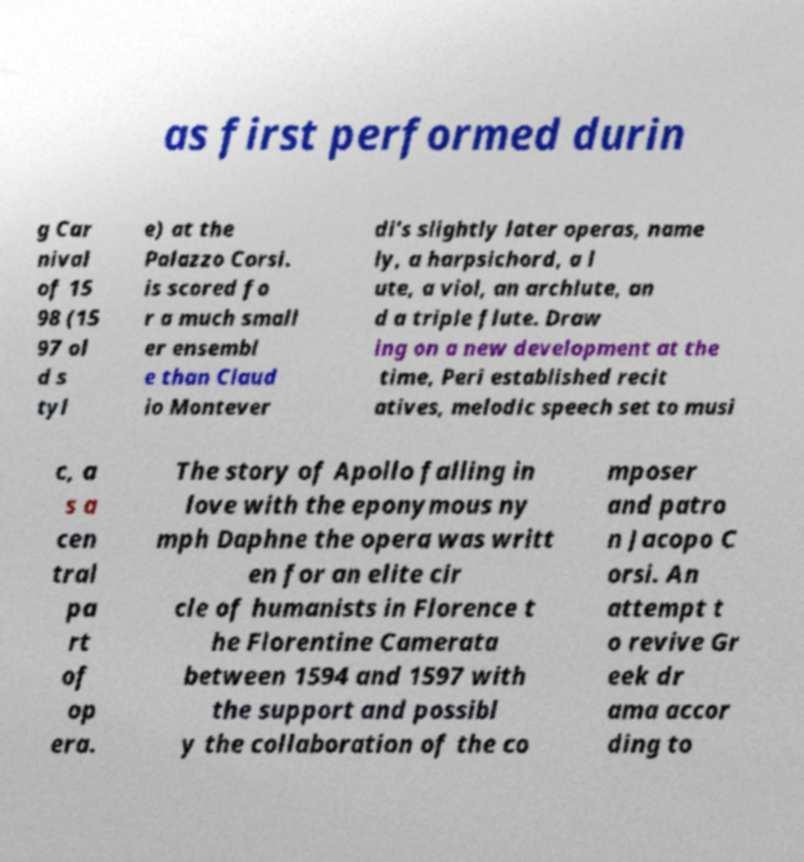Could you extract and type out the text from this image? as first performed durin g Car nival of 15 98 (15 97 ol d s tyl e) at the Palazzo Corsi. is scored fo r a much small er ensembl e than Claud io Montever di's slightly later operas, name ly, a harpsichord, a l ute, a viol, an archlute, an d a triple flute. Draw ing on a new development at the time, Peri established recit atives, melodic speech set to musi c, a s a cen tral pa rt of op era. The story of Apollo falling in love with the eponymous ny mph Daphne the opera was writt en for an elite cir cle of humanists in Florence t he Florentine Camerata between 1594 and 1597 with the support and possibl y the collaboration of the co mposer and patro n Jacopo C orsi. An attempt t o revive Gr eek dr ama accor ding to 